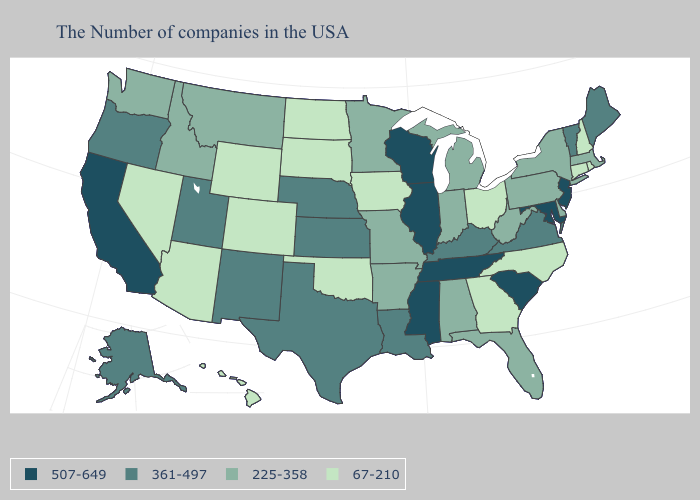Is the legend a continuous bar?
Short answer required. No. What is the value of Minnesota?
Keep it brief. 225-358. Does West Virginia have the lowest value in the USA?
Short answer required. No. Is the legend a continuous bar?
Be succinct. No. Does the first symbol in the legend represent the smallest category?
Write a very short answer. No. Does the first symbol in the legend represent the smallest category?
Quick response, please. No. Name the states that have a value in the range 507-649?
Write a very short answer. New Jersey, Maryland, South Carolina, Tennessee, Wisconsin, Illinois, Mississippi, California. What is the value of Connecticut?
Be succinct. 67-210. Does the map have missing data?
Answer briefly. No. Name the states that have a value in the range 225-358?
Keep it brief. Massachusetts, New York, Delaware, Pennsylvania, West Virginia, Florida, Michigan, Indiana, Alabama, Missouri, Arkansas, Minnesota, Montana, Idaho, Washington. What is the highest value in states that border Massachusetts?
Write a very short answer. 361-497. What is the value of Kansas?
Answer briefly. 361-497. Does Delaware have the lowest value in the USA?
Answer briefly. No. Name the states that have a value in the range 507-649?
Give a very brief answer. New Jersey, Maryland, South Carolina, Tennessee, Wisconsin, Illinois, Mississippi, California. 